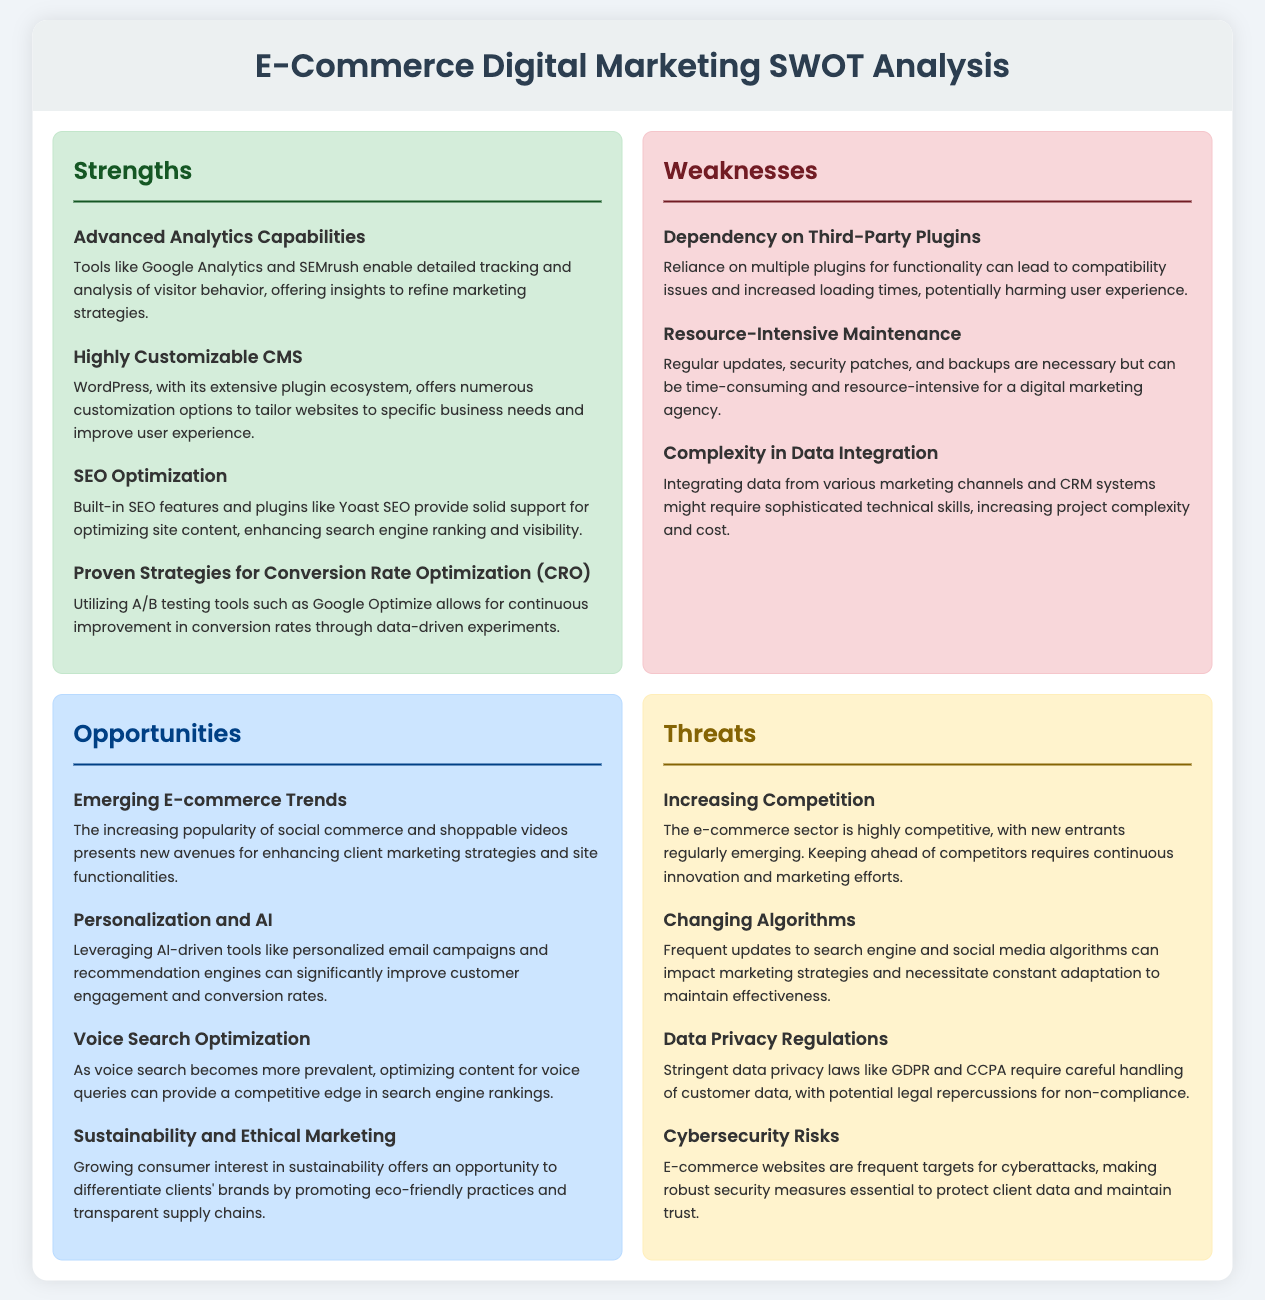What are two advanced analytics tools mentioned? The document lists Google Analytics and SEMrush as advanced analytics capabilities for detailed tracking and analysis of visitor behavior.
Answer: Google Analytics, SEMrush What is a primary disadvantage related to third-party plugins? The document states that reliance on multiple plugins can lead to compatibility issues and increased loading times, potentially harming user experience.
Answer: Compatibility issues What trend in e-commerce could enhance marketing strategies? The document highlights the increasing popularity of social commerce and shoppable videos as emerging trends.
Answer: Social commerce, shoppable videos What is a significant opportunity mentioned regarding AI? The document discusses leveraging AI-driven tools such as personalized email campaigns and recommendation engines to improve customer engagement.
Answer: Personalized email campaigns What threat is related to frequent updates from search engines? The document notes that changing algorithms can impact marketing strategies and necessitate constant adaptation.
Answer: Changing algorithms Which CMS is highlighted for its customization options? The document mentions WordPress as a highly customizable content management system with an extensive plugin ecosystem.
Answer: WordPress How are data privacy regulations described? The document states that stringent data privacy laws like GDPR and CCPA require careful handling of customer data.
Answer: Stringent data privacy laws What is a major factor in the e-commerce sector according to the analysis? The document emphasizes that the e-commerce sector is highly competitive, requiring continuous innovation and marketing efforts.
Answer: Highly competitive 